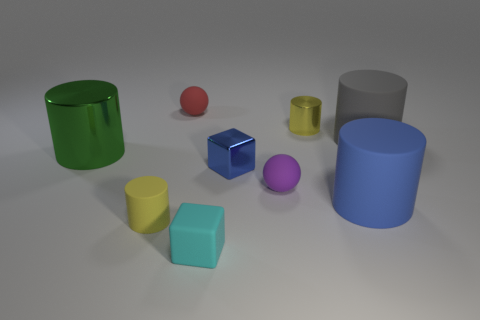There is a big object left of the cyan thing; does it have the same shape as the gray thing?
Ensure brevity in your answer.  Yes. There is another small thing that is the same shape as the yellow metal thing; what color is it?
Ensure brevity in your answer.  Yellow. Is there anything else that is the same shape as the big gray object?
Keep it short and to the point. Yes. Is the number of small yellow objects that are behind the purple rubber ball the same as the number of big yellow matte objects?
Offer a very short reply. No. What number of things are both to the left of the small red object and behind the green object?
Your answer should be very brief. 0. What size is the other shiny object that is the same shape as the green metal thing?
Provide a short and direct response. Small. What number of brown blocks have the same material as the purple thing?
Keep it short and to the point. 0. Are there fewer small yellow cylinders behind the large blue rubber cylinder than yellow rubber cylinders?
Provide a short and direct response. No. What number of small cylinders are there?
Provide a short and direct response. 2. What number of big rubber cylinders are the same color as the metal cube?
Keep it short and to the point. 1. 